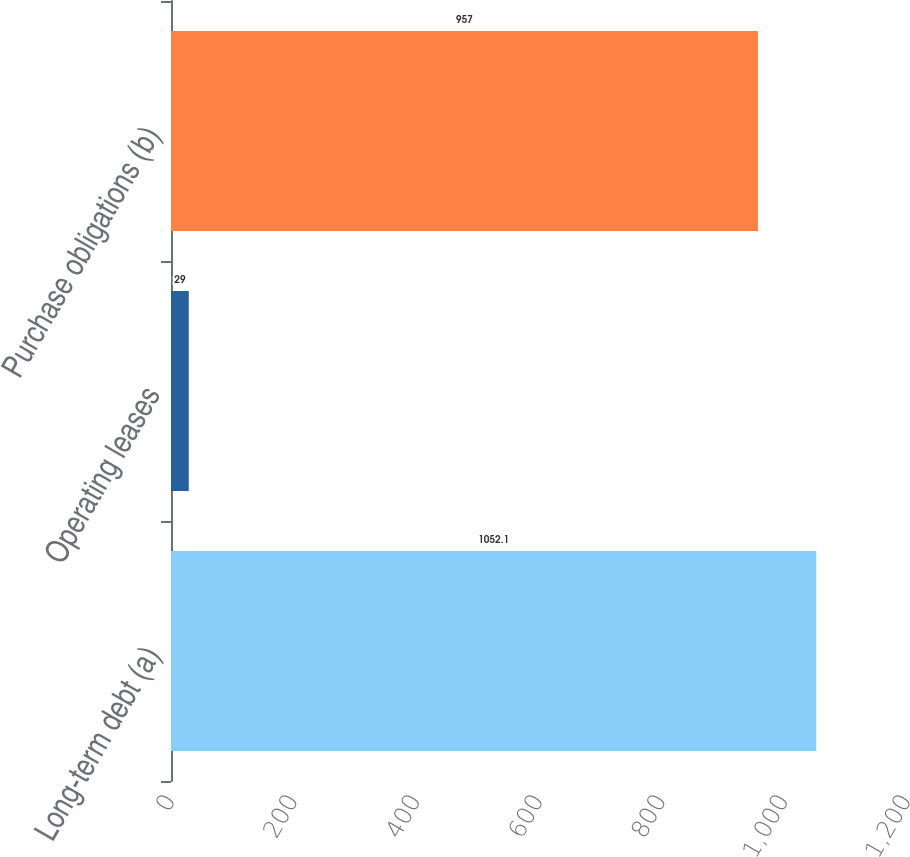Convert chart. <chart><loc_0><loc_0><loc_500><loc_500><bar_chart><fcel>Long-term debt (a)<fcel>Operating leases<fcel>Purchase obligations (b)<nl><fcel>1052.1<fcel>29<fcel>957<nl></chart> 